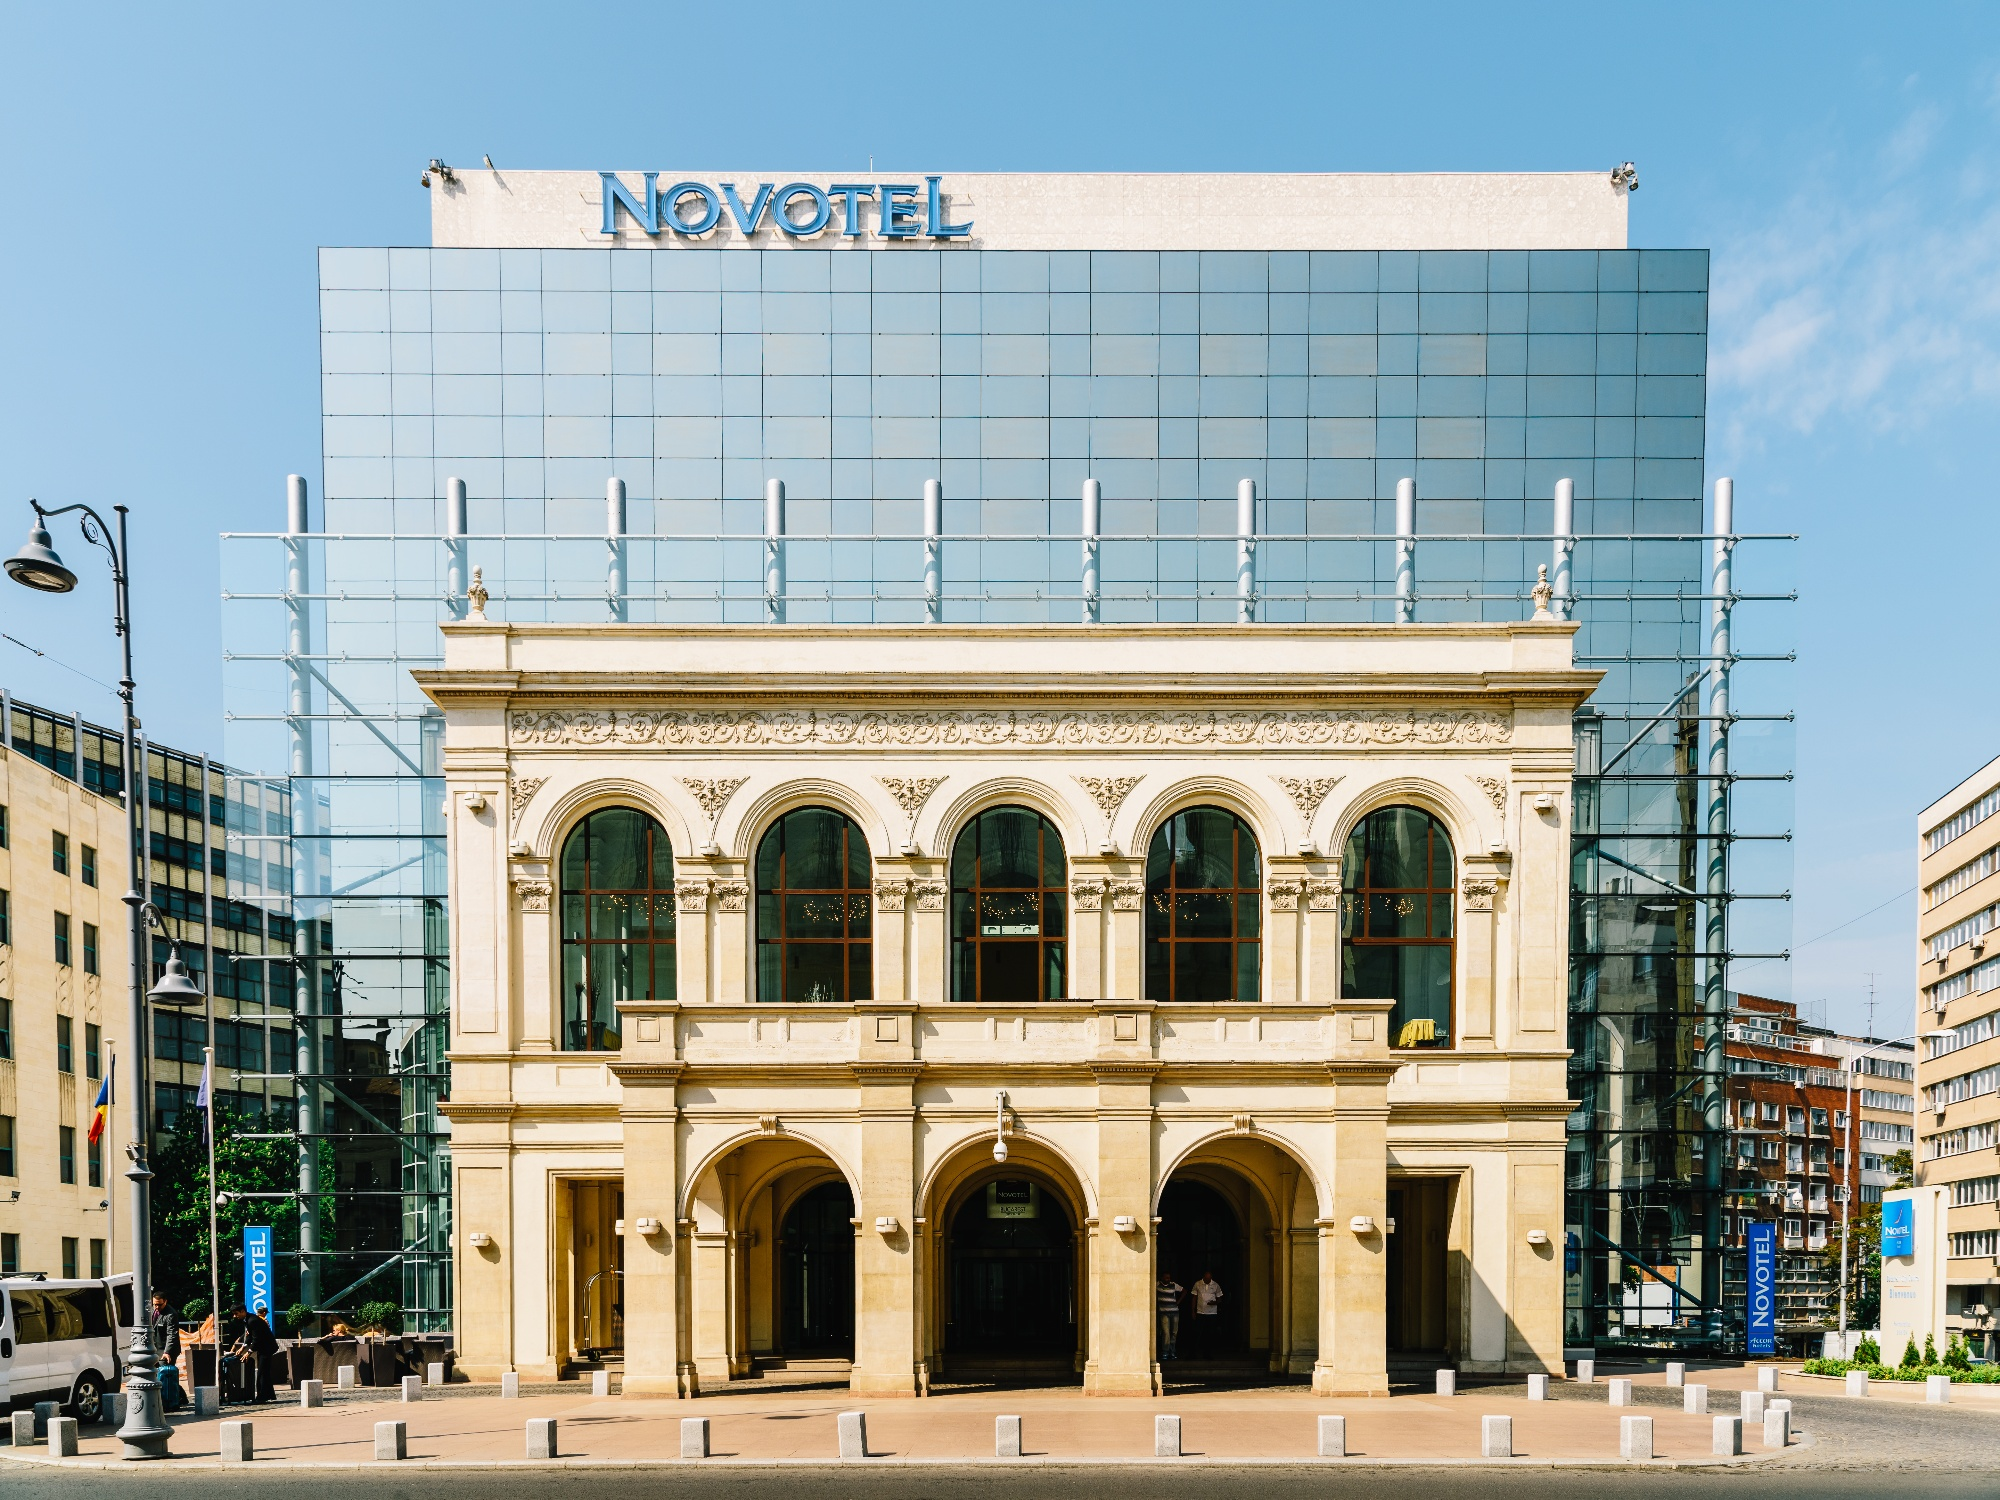Explain the visual content of the image in great detail. The image features the Novotel Hotel in Warsaw, Poland, prominently displaying a juxtaposition of architectural epochs. The upper modern section of the building shows a simplistic yet elegant glass facade reflecting the sky. A 'Novotel' sign is mounted on top against the vivid blue backdrop. Notably, part of the structure is adorned with scaffolding, indicating renovations or maintenance. This is contrasted sharply by the base of the hotel, which showcases richly ornate, older architectural designs with arched windows and elaborate detailing around the doorways. Surrounding the hotel, the street is visible with pedestrians and parked vehicles, adding a layer of everyday urban life to the scene. This detailed representation gives us not only architectural insight but also a glimpse into the bustling city life of Warsaw. 